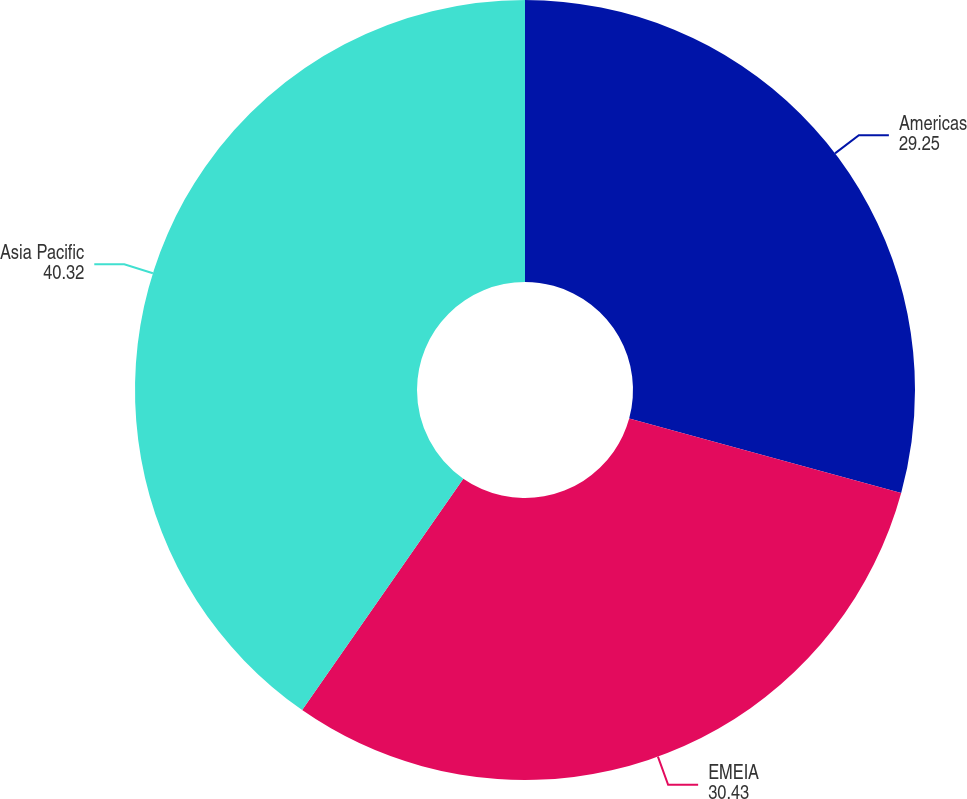Convert chart to OTSL. <chart><loc_0><loc_0><loc_500><loc_500><pie_chart><fcel>Americas<fcel>EMEIA<fcel>Asia Pacific<nl><fcel>29.25%<fcel>30.43%<fcel>40.32%<nl></chart> 